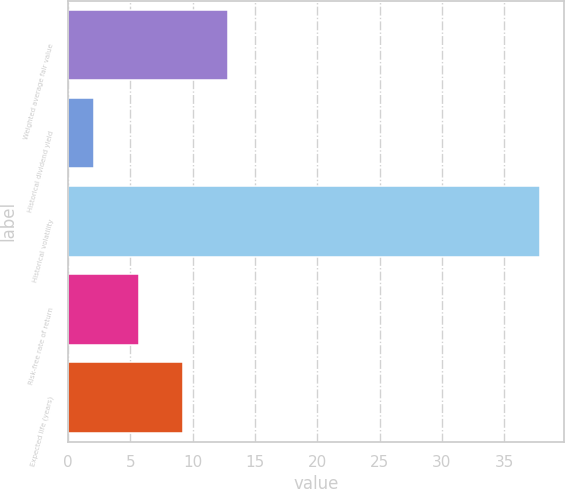Convert chart to OTSL. <chart><loc_0><loc_0><loc_500><loc_500><bar_chart><fcel>Weighted average fair value<fcel>Historical dividend yield<fcel>Historical volatility<fcel>Risk-free rate of return<fcel>Expected life (years)<nl><fcel>12.84<fcel>2.1<fcel>37.9<fcel>5.68<fcel>9.26<nl></chart> 